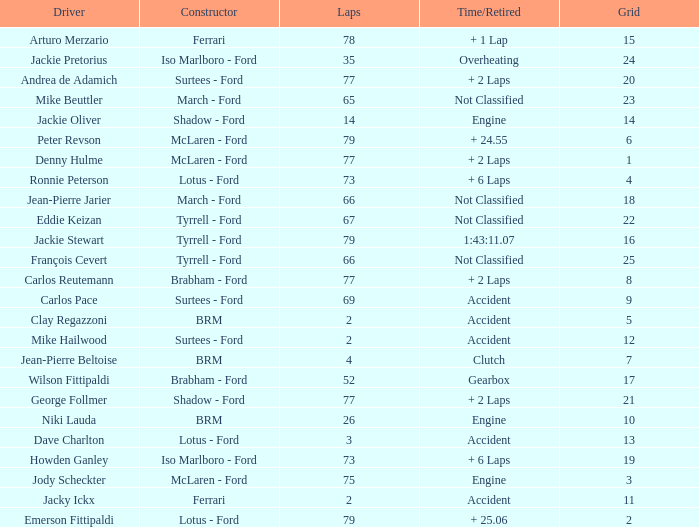What is the total grid with laps less than 2? None. Would you mind parsing the complete table? {'header': ['Driver', 'Constructor', 'Laps', 'Time/Retired', 'Grid'], 'rows': [['Arturo Merzario', 'Ferrari', '78', '+ 1 Lap', '15'], ['Jackie Pretorius', 'Iso Marlboro - Ford', '35', 'Overheating', '24'], ['Andrea de Adamich', 'Surtees - Ford', '77', '+ 2 Laps', '20'], ['Mike Beuttler', 'March - Ford', '65', 'Not Classified', '23'], ['Jackie Oliver', 'Shadow - Ford', '14', 'Engine', '14'], ['Peter Revson', 'McLaren - Ford', '79', '+ 24.55', '6'], ['Denny Hulme', 'McLaren - Ford', '77', '+ 2 Laps', '1'], ['Ronnie Peterson', 'Lotus - Ford', '73', '+ 6 Laps', '4'], ['Jean-Pierre Jarier', 'March - Ford', '66', 'Not Classified', '18'], ['Eddie Keizan', 'Tyrrell - Ford', '67', 'Not Classified', '22'], ['Jackie Stewart', 'Tyrrell - Ford', '79', '1:43:11.07', '16'], ['François Cevert', 'Tyrrell - Ford', '66', 'Not Classified', '25'], ['Carlos Reutemann', 'Brabham - Ford', '77', '+ 2 Laps', '8'], ['Carlos Pace', 'Surtees - Ford', '69', 'Accident', '9'], ['Clay Regazzoni', 'BRM', '2', 'Accident', '5'], ['Mike Hailwood', 'Surtees - Ford', '2', 'Accident', '12'], ['Jean-Pierre Beltoise', 'BRM', '4', 'Clutch', '7'], ['Wilson Fittipaldi', 'Brabham - Ford', '52', 'Gearbox', '17'], ['George Follmer', 'Shadow - Ford', '77', '+ 2 Laps', '21'], ['Niki Lauda', 'BRM', '26', 'Engine', '10'], ['Dave Charlton', 'Lotus - Ford', '3', 'Accident', '13'], ['Howden Ganley', 'Iso Marlboro - Ford', '73', '+ 6 Laps', '19'], ['Jody Scheckter', 'McLaren - Ford', '75', 'Engine', '3'], ['Jacky Ickx', 'Ferrari', '2', 'Accident', '11'], ['Emerson Fittipaldi', 'Lotus - Ford', '79', '+ 25.06', '2']]} 